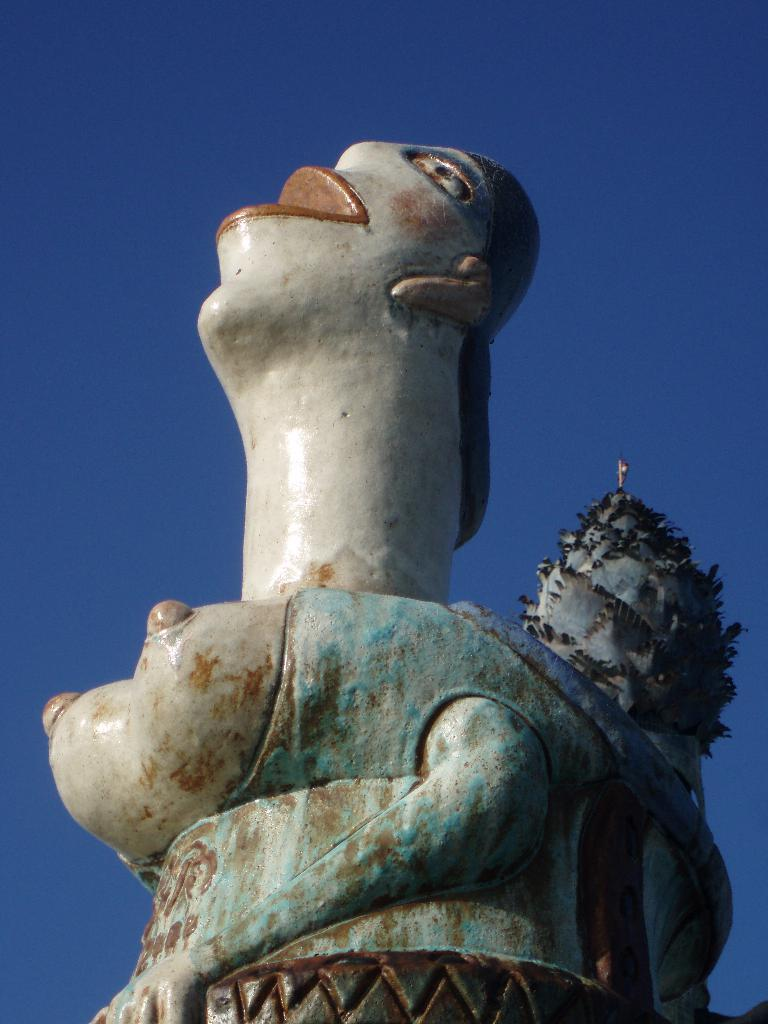What is the main subject of the image? There is a sculpture in the image. What can be seen in the background of the image? The sky is visible in the background of the image. What type of instrument is being played in the image? There is no instrument present in the image; it features a sculpture and the sky. How many leaves can be seen on the sculpture in the image? There are no leaves present on the sculpture in the image. 